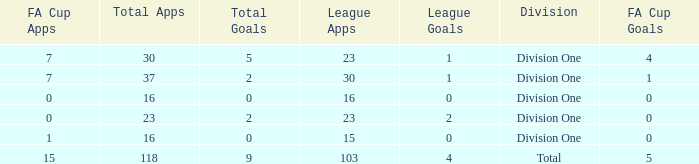It has a FA Cup Goals smaller than 4, and a FA Cup Apps larger than 7, what is the total number of total apps? 0.0. 